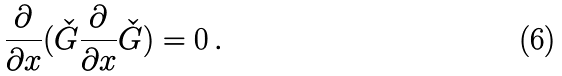<formula> <loc_0><loc_0><loc_500><loc_500>\frac { \partial } { \partial x } ( \check { G } \frac { \partial } { \partial x } \check { G } ) = 0 \, .</formula> 